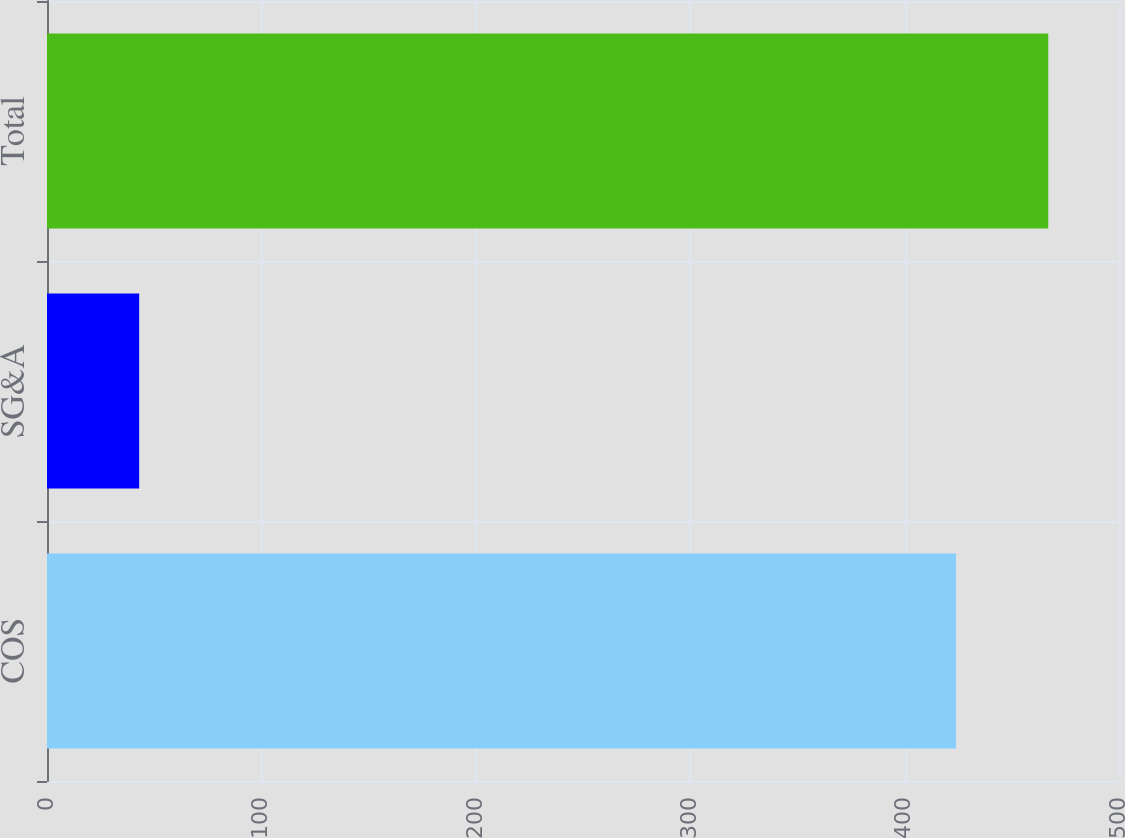Convert chart to OTSL. <chart><loc_0><loc_0><loc_500><loc_500><bar_chart><fcel>COS<fcel>SG&A<fcel>Total<nl><fcel>424<fcel>43<fcel>467<nl></chart> 